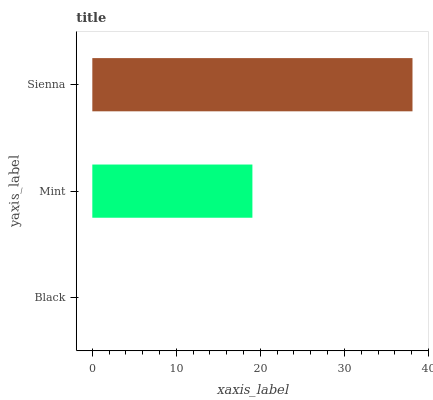Is Black the minimum?
Answer yes or no. Yes. Is Sienna the maximum?
Answer yes or no. Yes. Is Mint the minimum?
Answer yes or no. No. Is Mint the maximum?
Answer yes or no. No. Is Mint greater than Black?
Answer yes or no. Yes. Is Black less than Mint?
Answer yes or no. Yes. Is Black greater than Mint?
Answer yes or no. No. Is Mint less than Black?
Answer yes or no. No. Is Mint the high median?
Answer yes or no. Yes. Is Mint the low median?
Answer yes or no. Yes. Is Black the high median?
Answer yes or no. No. Is Black the low median?
Answer yes or no. No. 